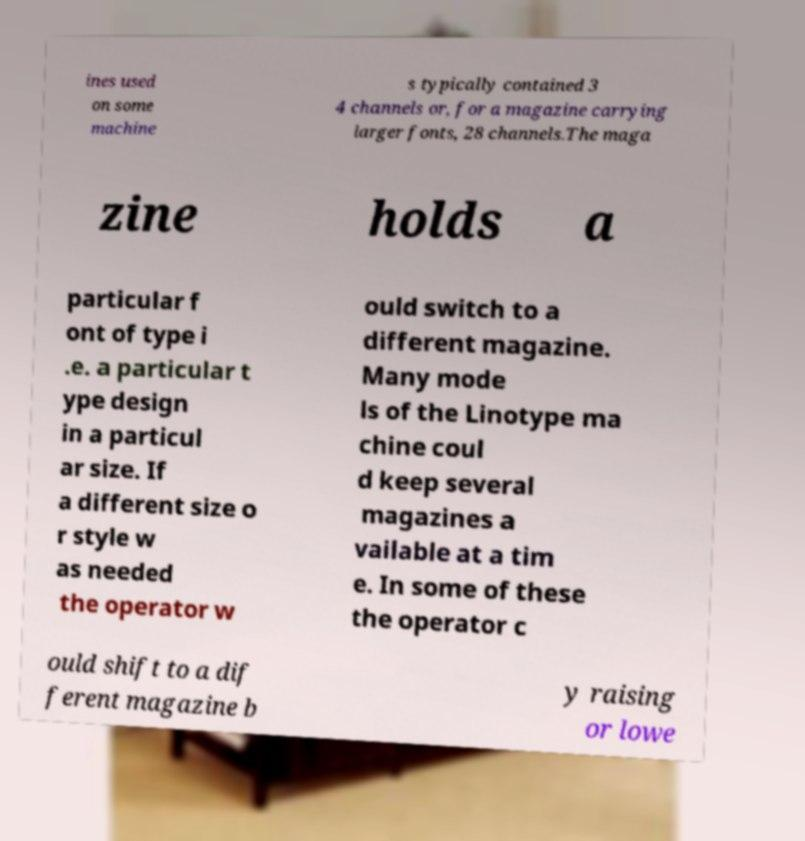I need the written content from this picture converted into text. Can you do that? ines used on some machine s typically contained 3 4 channels or, for a magazine carrying larger fonts, 28 channels.The maga zine holds a particular f ont of type i .e. a particular t ype design in a particul ar size. If a different size o r style w as needed the operator w ould switch to a different magazine. Many mode ls of the Linotype ma chine coul d keep several magazines a vailable at a tim e. In some of these the operator c ould shift to a dif ferent magazine b y raising or lowe 